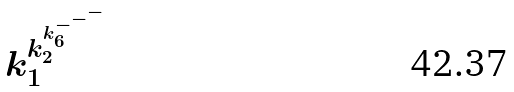<formula> <loc_0><loc_0><loc_500><loc_500>k _ { 1 } ^ { k _ { 2 } ^ { k _ { 6 } ^ { - ^ { - ^ { - } } } } }</formula> 